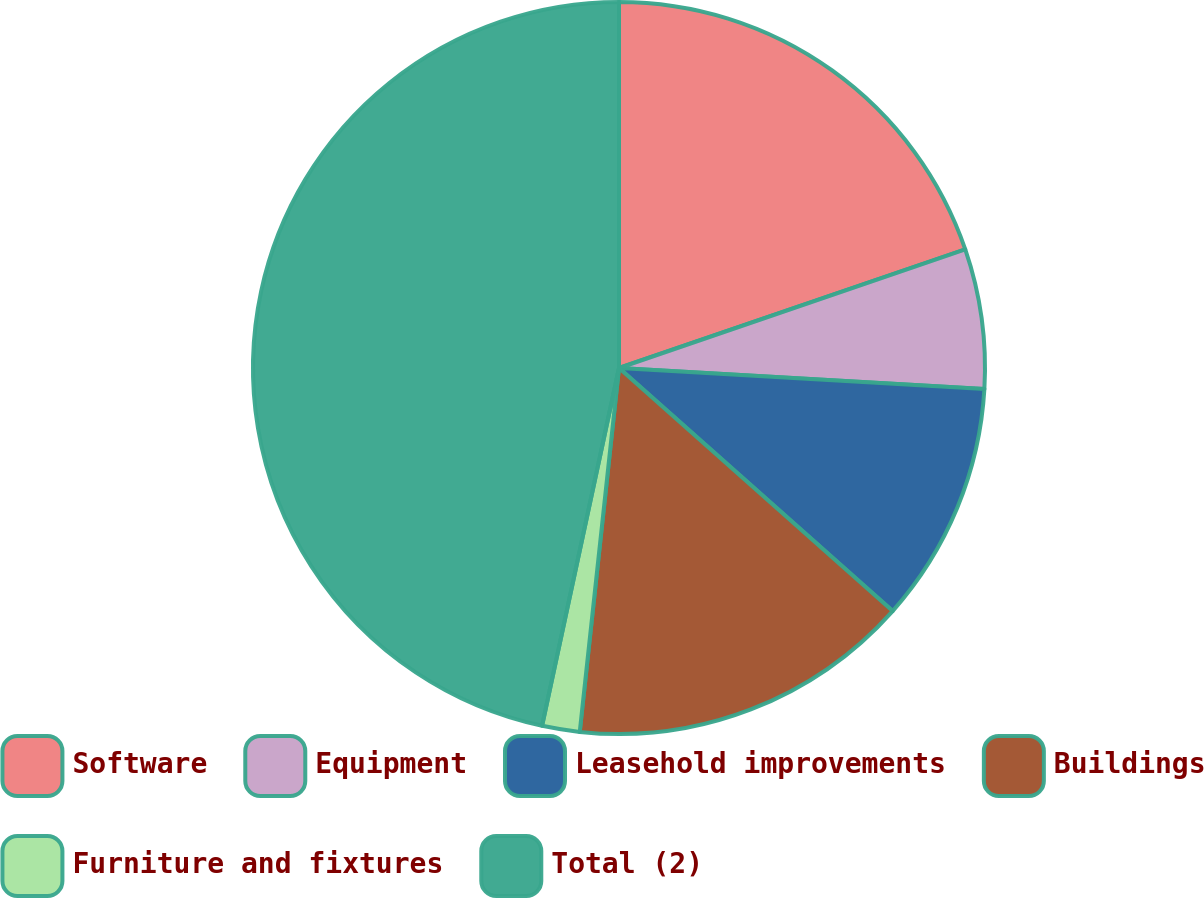Convert chart. <chart><loc_0><loc_0><loc_500><loc_500><pie_chart><fcel>Software<fcel>Equipment<fcel>Leasehold improvements<fcel>Buildings<fcel>Furniture and fixtures<fcel>Total (2)<nl><fcel>19.75%<fcel>6.16%<fcel>10.65%<fcel>15.15%<fcel>1.66%<fcel>46.63%<nl></chart> 